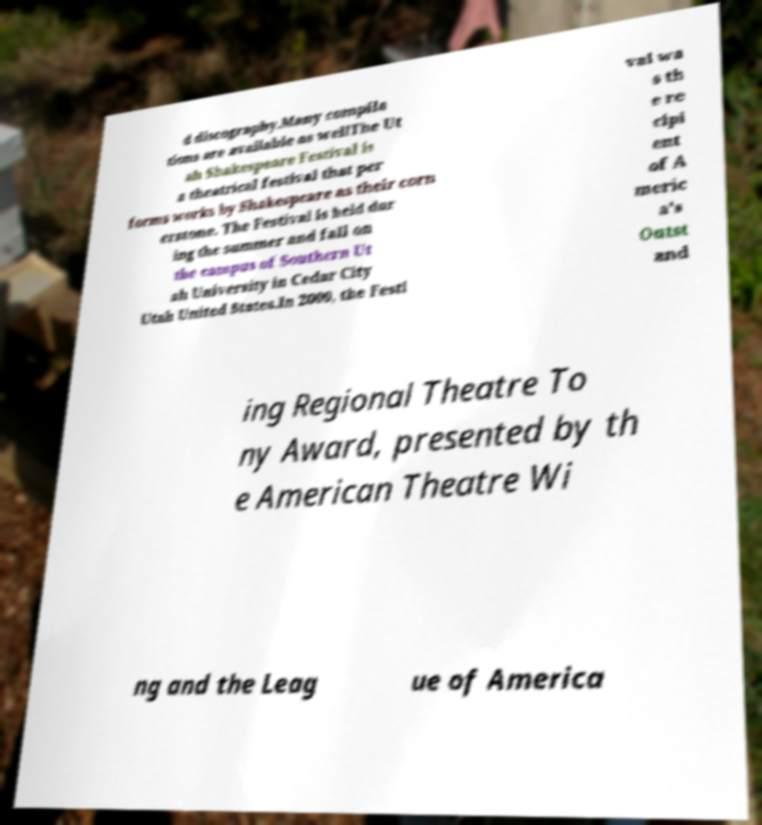What messages or text are displayed in this image? I need them in a readable, typed format. d discography.Many compila tions are available as wellThe Ut ah Shakespeare Festival is a theatrical festival that per forms works by Shakespeare as their corn erstone. The Festival is held dur ing the summer and fall on the campus of Southern Ut ah University in Cedar City Utah United States.In 2000, the Festi val wa s th e re cipi ent of A meric a's Outst and ing Regional Theatre To ny Award, presented by th e American Theatre Wi ng and the Leag ue of America 